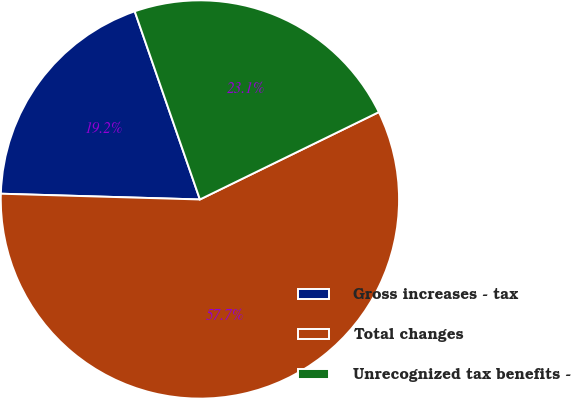Convert chart. <chart><loc_0><loc_0><loc_500><loc_500><pie_chart><fcel>Gross increases - tax<fcel>Total changes<fcel>Unrecognized tax benefits -<nl><fcel>19.23%<fcel>57.69%<fcel>23.08%<nl></chart> 